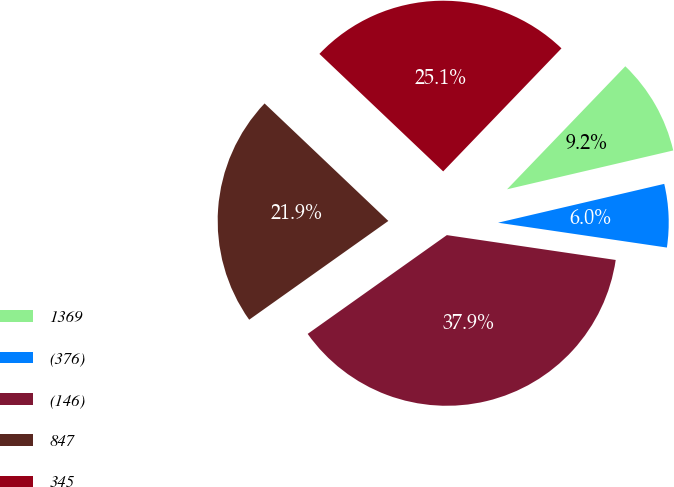<chart> <loc_0><loc_0><loc_500><loc_500><pie_chart><fcel>1369<fcel>(376)<fcel>(146)<fcel>847<fcel>345<nl><fcel>9.16%<fcel>5.98%<fcel>37.85%<fcel>21.91%<fcel>25.1%<nl></chart> 